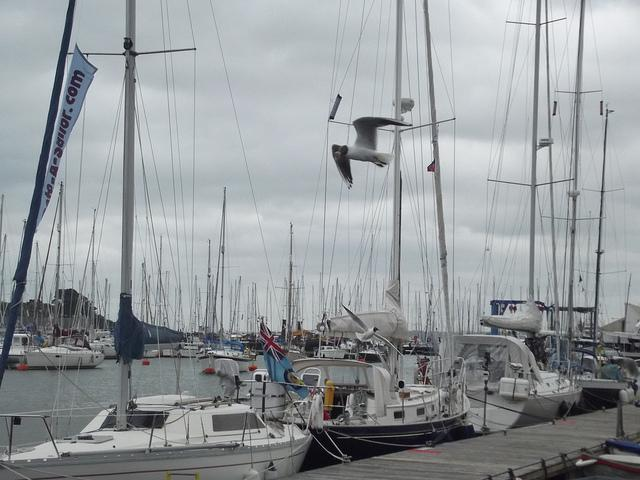What baby name is related to this place? Please explain your reasoning. marina. This place is used to park boats. 